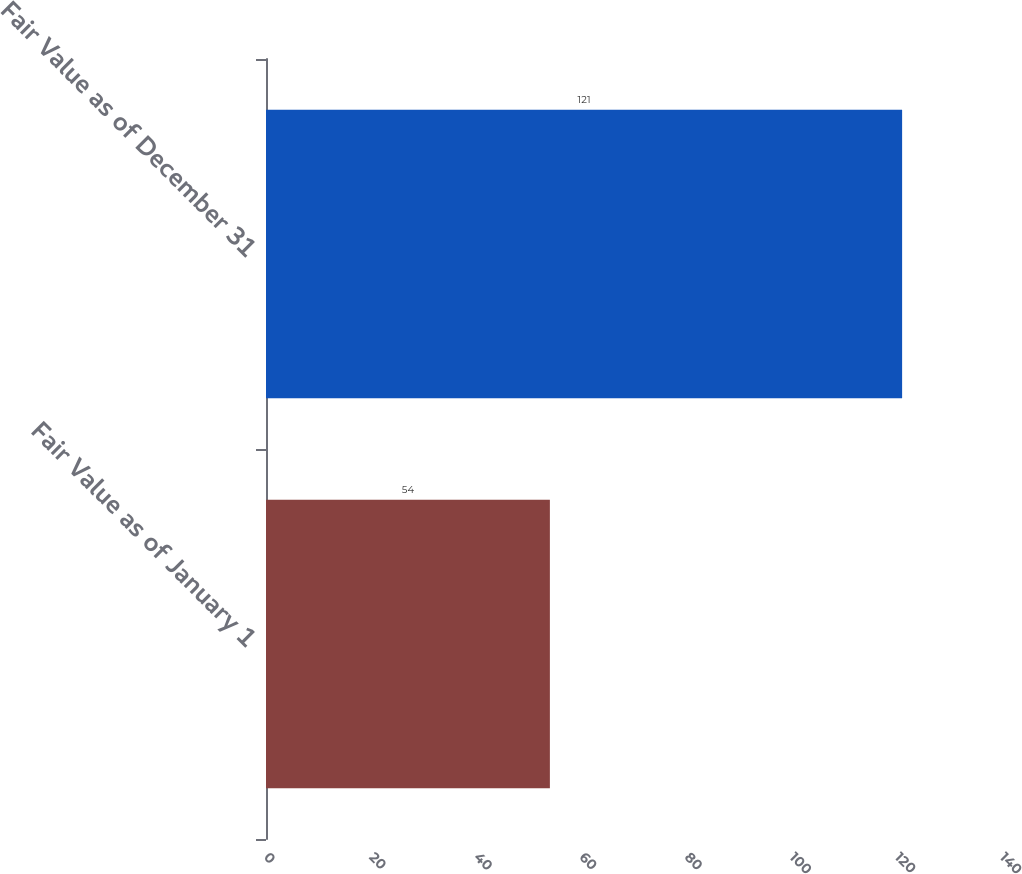Convert chart to OTSL. <chart><loc_0><loc_0><loc_500><loc_500><bar_chart><fcel>Fair Value as of January 1<fcel>Fair Value as of December 31<nl><fcel>54<fcel>121<nl></chart> 